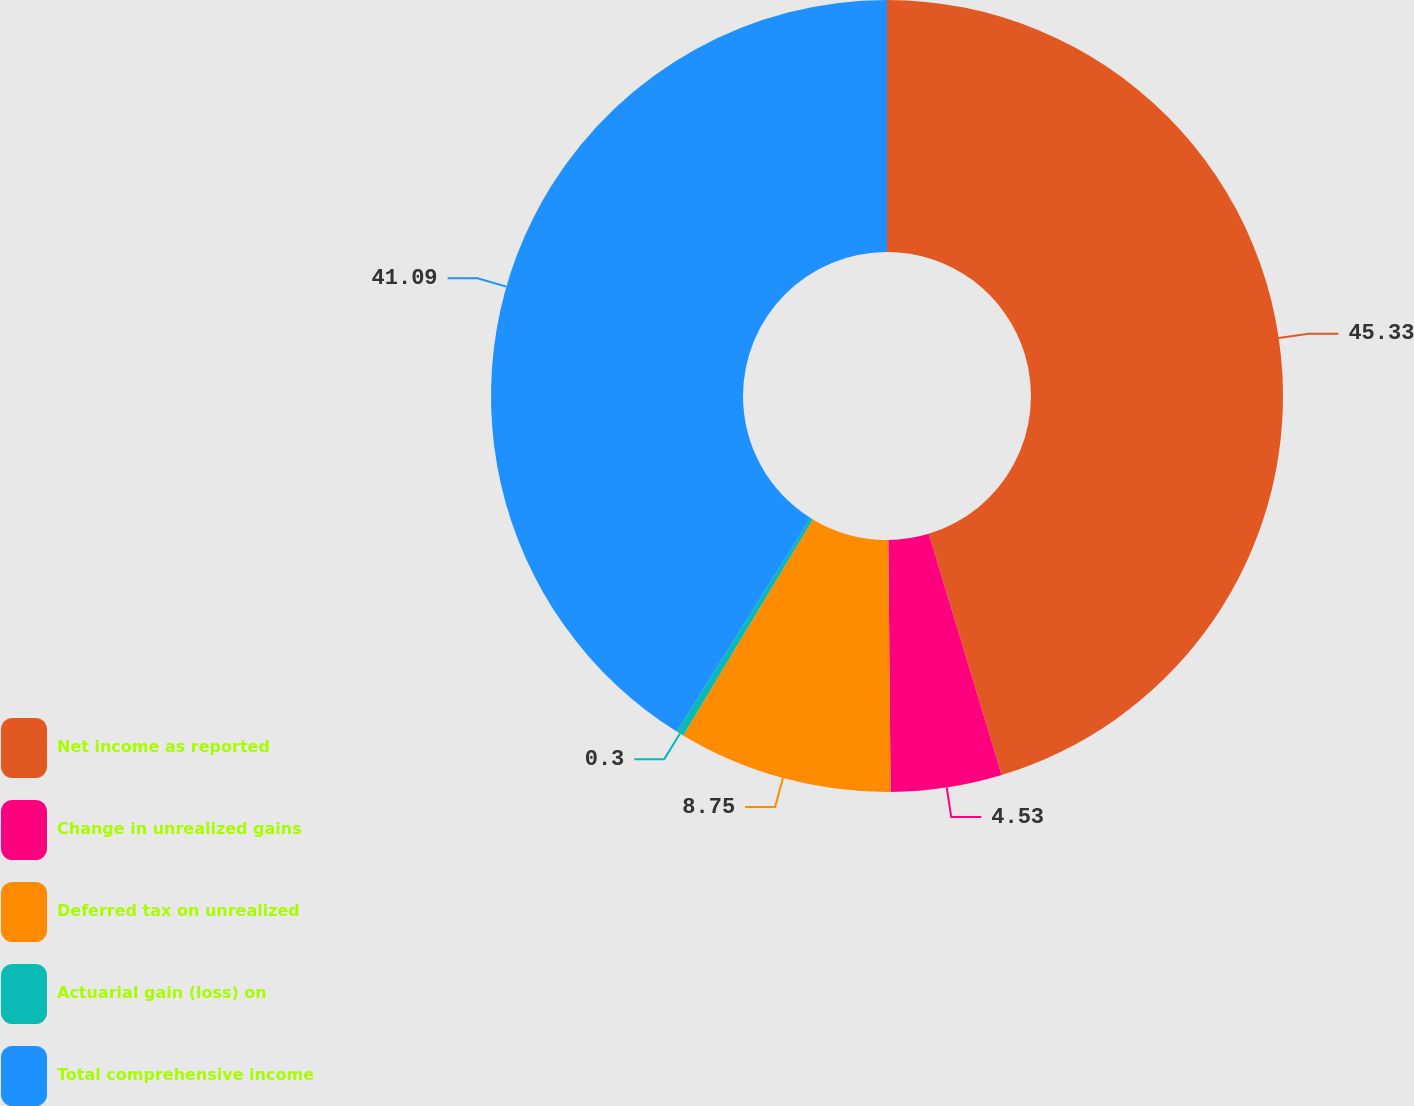Convert chart. <chart><loc_0><loc_0><loc_500><loc_500><pie_chart><fcel>Net income as reported<fcel>Change in unrealized gains<fcel>Deferred tax on unrealized<fcel>Actuarial gain (loss) on<fcel>Total comprehensive income<nl><fcel>45.32%<fcel>4.53%<fcel>8.75%<fcel>0.3%<fcel>41.09%<nl></chart> 